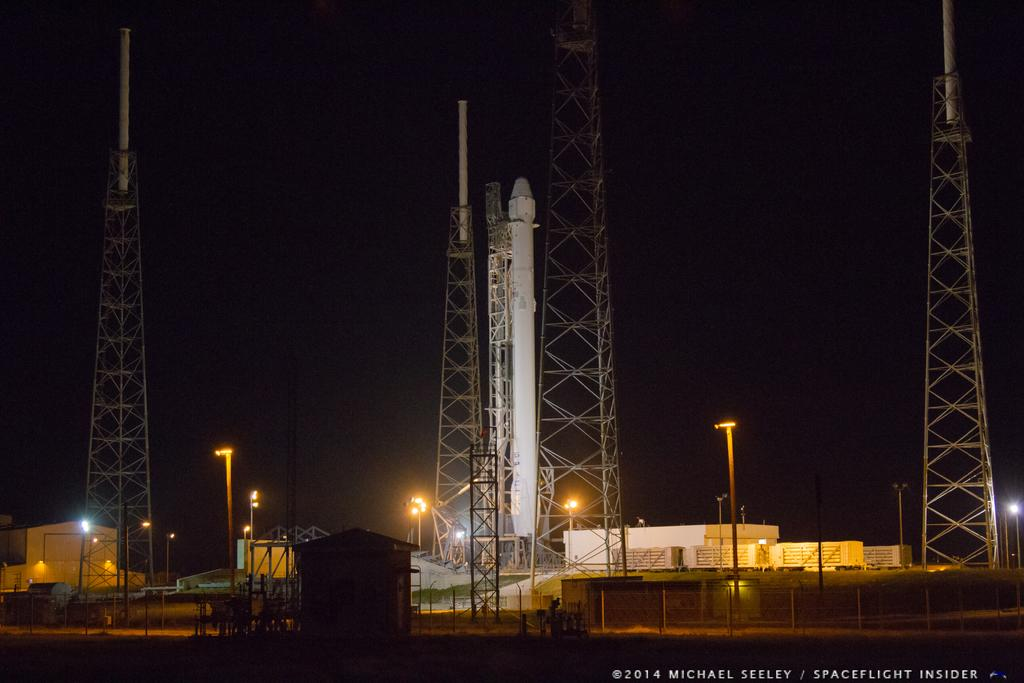What type of structure can be seen in the image? There is a fence in the image. What other structures are present in the image? There are sheds and poles in the image. Are there any lighting features in the image? Yes, there are lights in the image. How many towers are near the rocket in the image? There are four towers near the rocket in the image. Is there any additional information about the image itself? Yes, there is a watermark on the image. What type of orange is being used as a decoration in the image? There is no orange present in the image; it features a fence, sheds, poles, lights, and towers near a rocket. What type of education is being offered in the image? There is no reference to education in the image; it focuses on structures and lighting. 